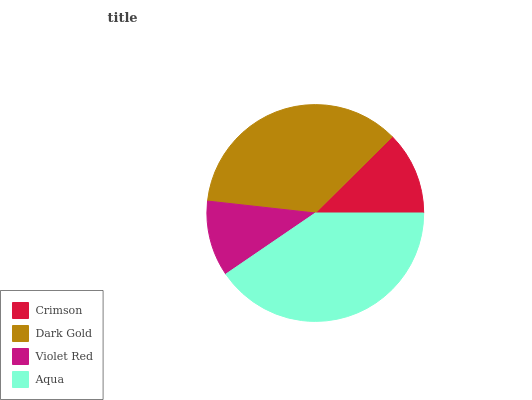Is Violet Red the minimum?
Answer yes or no. Yes. Is Aqua the maximum?
Answer yes or no. Yes. Is Dark Gold the minimum?
Answer yes or no. No. Is Dark Gold the maximum?
Answer yes or no. No. Is Dark Gold greater than Crimson?
Answer yes or no. Yes. Is Crimson less than Dark Gold?
Answer yes or no. Yes. Is Crimson greater than Dark Gold?
Answer yes or no. No. Is Dark Gold less than Crimson?
Answer yes or no. No. Is Dark Gold the high median?
Answer yes or no. Yes. Is Crimson the low median?
Answer yes or no. Yes. Is Aqua the high median?
Answer yes or no. No. Is Dark Gold the low median?
Answer yes or no. No. 